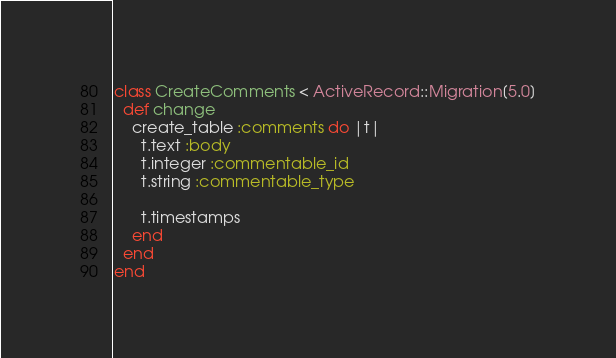Convert code to text. <code><loc_0><loc_0><loc_500><loc_500><_Ruby_>class CreateComments < ActiveRecord::Migration[5.0]
  def change
    create_table :comments do |t|
      t.text :body
      t.integer :commentable_id
      t.string :commentable_type

      t.timestamps
    end
  end
end
</code> 